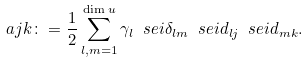<formula> <loc_0><loc_0><loc_500><loc_500>\ a j k \colon = \frac { 1 } { 2 } \sum _ { l , m = 1 } ^ { \dim u } \gamma _ { l } \ s e i \delta _ { l m } \ s e i d _ { l j } \ s e i d _ { m k } .</formula> 